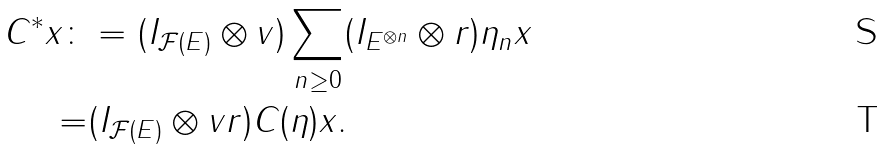<formula> <loc_0><loc_0><loc_500><loc_500>C ^ { * } x \colon & = ( I _ { \mathcal { F } ( E ) } \otimes v ) \sum _ { n \geq 0 } ( I _ { E ^ { \otimes n } } \otimes r ) \eta _ { n } x \\ = & ( I _ { \mathcal { F } ( E ) } \otimes v r ) C ( \eta ) x .</formula> 